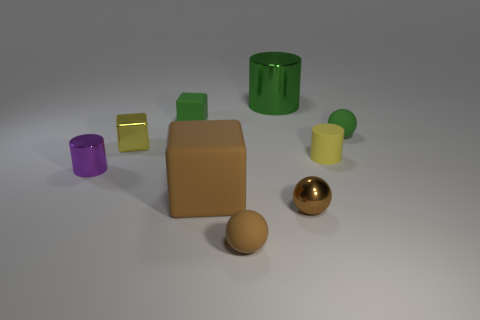Do the brown metallic thing on the right side of the green rubber cube and the sphere that is to the right of the matte cylinder have the same size?
Provide a succinct answer. Yes. What number of other things are the same size as the purple shiny cylinder?
Give a very brief answer. 6. The small cylinder on the left side of the tiny yellow thing to the left of the metallic cylinder that is behind the yellow metal block is made of what material?
Your response must be concise. Metal. Do the brown metal ball and the green object that is to the right of the green cylinder have the same size?
Make the answer very short. Yes. What size is the metallic thing that is both in front of the shiny cube and behind the large brown matte block?
Your response must be concise. Small. Are there any tiny rubber cylinders that have the same color as the big metallic cylinder?
Provide a short and direct response. No. The rubber ball that is in front of the small green object that is in front of the tiny rubber block is what color?
Offer a terse response. Brown. Are there fewer things that are behind the purple thing than small brown spheres to the right of the tiny shiny ball?
Keep it short and to the point. No. Does the purple metal thing have the same size as the brown shiny ball?
Give a very brief answer. Yes. The tiny rubber object that is both left of the big cylinder and behind the small metallic ball has what shape?
Give a very brief answer. Cube. 